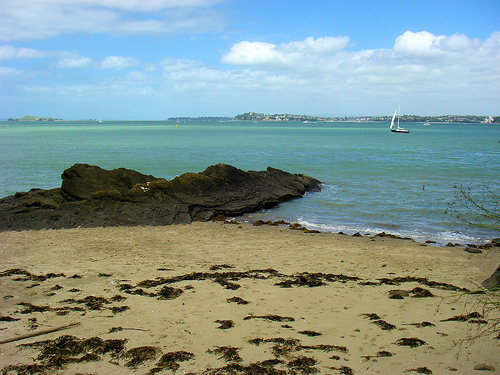<image>
Is the boat on the sea? Yes. Looking at the image, I can see the boat is positioned on top of the sea, with the sea providing support. Where is the boat in relation to the sand? Is it on the sand? No. The boat is not positioned on the sand. They may be near each other, but the boat is not supported by or resting on top of the sand. 